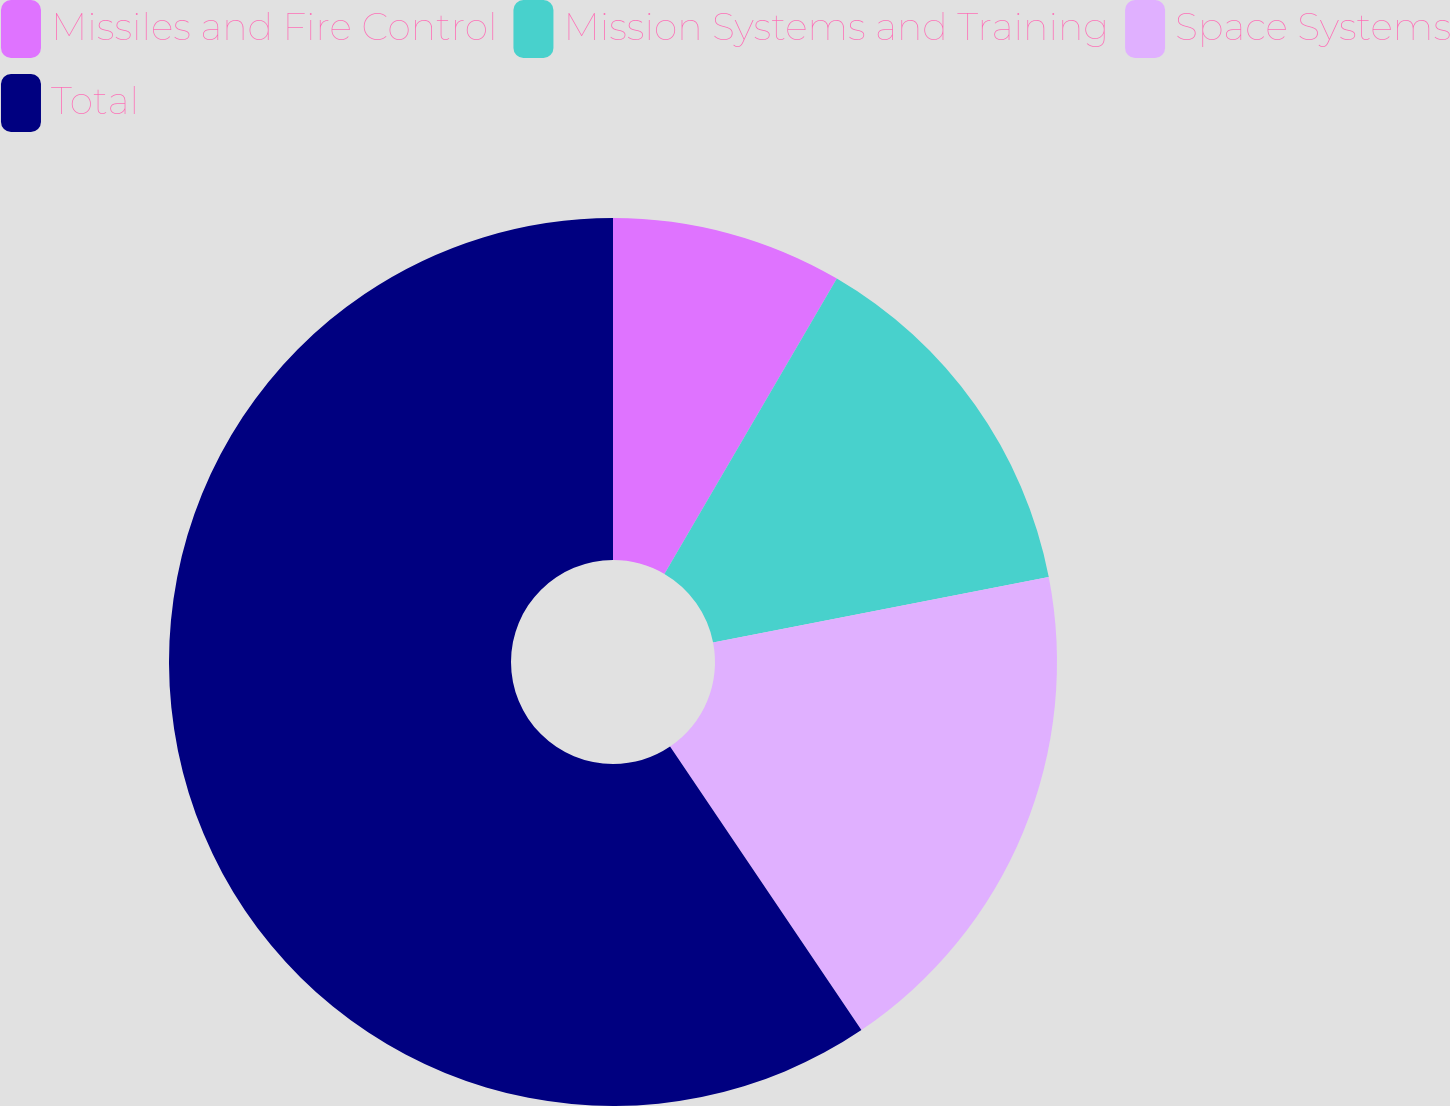Convert chart to OTSL. <chart><loc_0><loc_0><loc_500><loc_500><pie_chart><fcel>Missiles and Fire Control<fcel>Mission Systems and Training<fcel>Space Systems<fcel>Total<nl><fcel>8.41%<fcel>13.52%<fcel>18.62%<fcel>59.45%<nl></chart> 